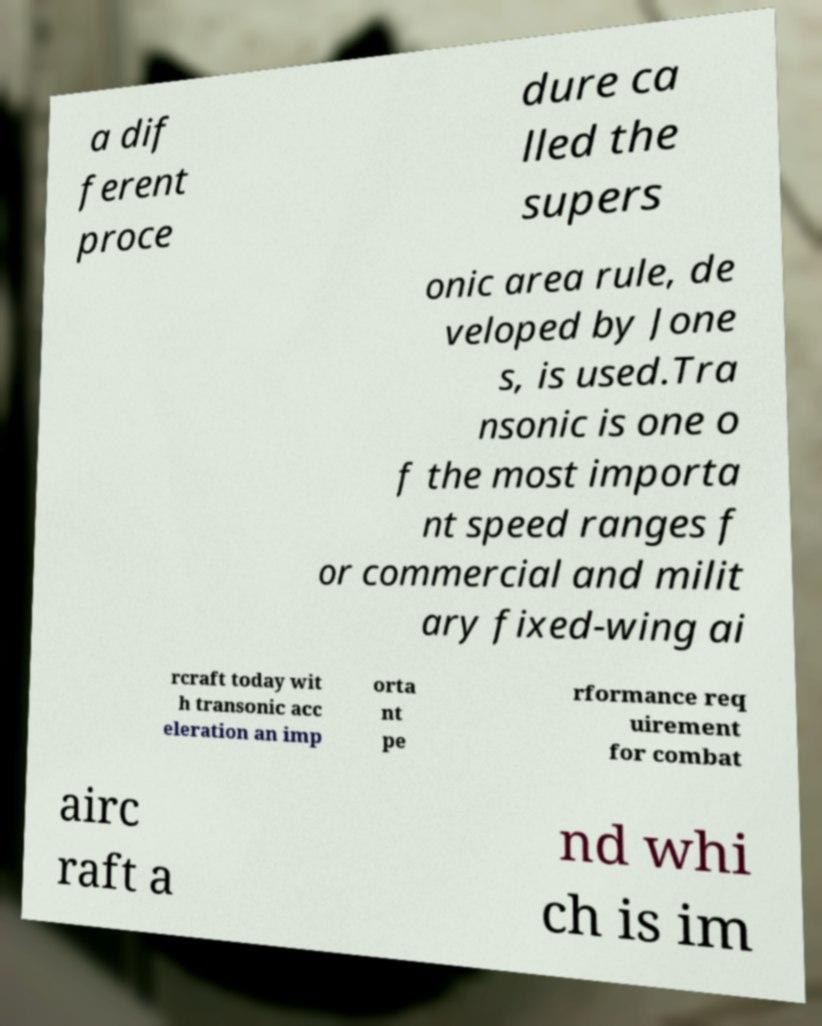Could you extract and type out the text from this image? a dif ferent proce dure ca lled the supers onic area rule, de veloped by Jone s, is used.Tra nsonic is one o f the most importa nt speed ranges f or commercial and milit ary fixed-wing ai rcraft today wit h transonic acc eleration an imp orta nt pe rformance req uirement for combat airc raft a nd whi ch is im 